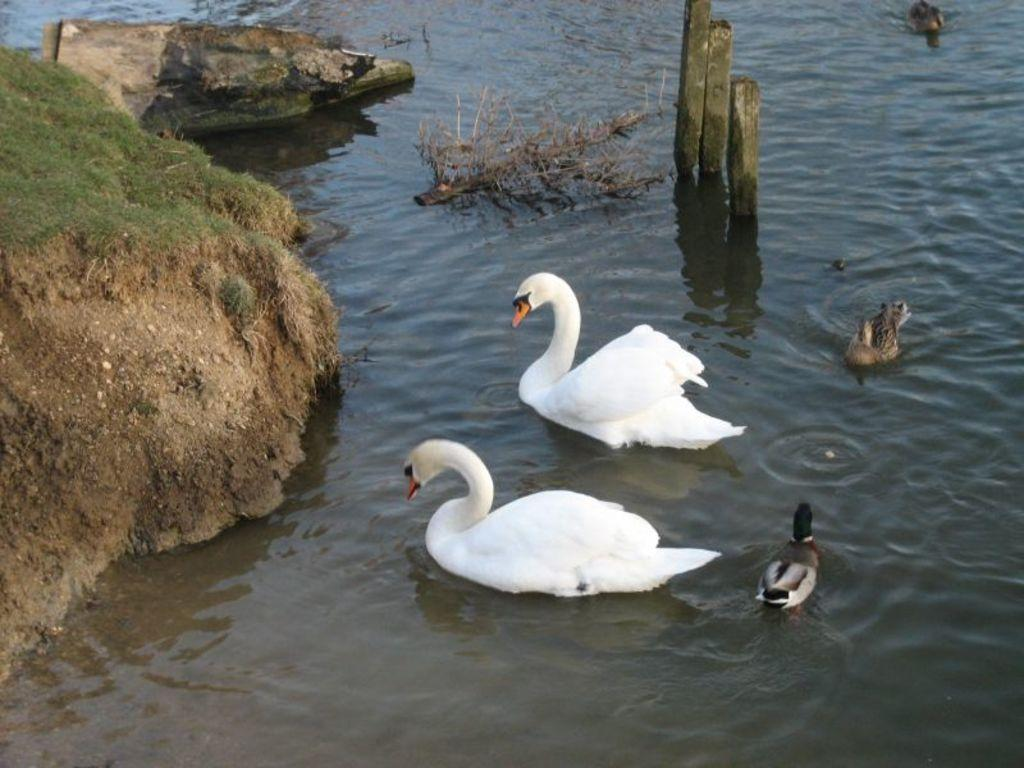What type of animals can be seen in the image? Birds can be seen in the water in the image. What structures are present in the image? There are wooden poles in the image. What type of vegetation is visible in the image? There are plants and grass in the image. What natural elements can be seen in the image? There are rocks in the image. What type of trade is being conducted in the image? There is no indication of any trade being conducted in the image. Can you describe the form of the chain in the image? There is no chain present in the image. 